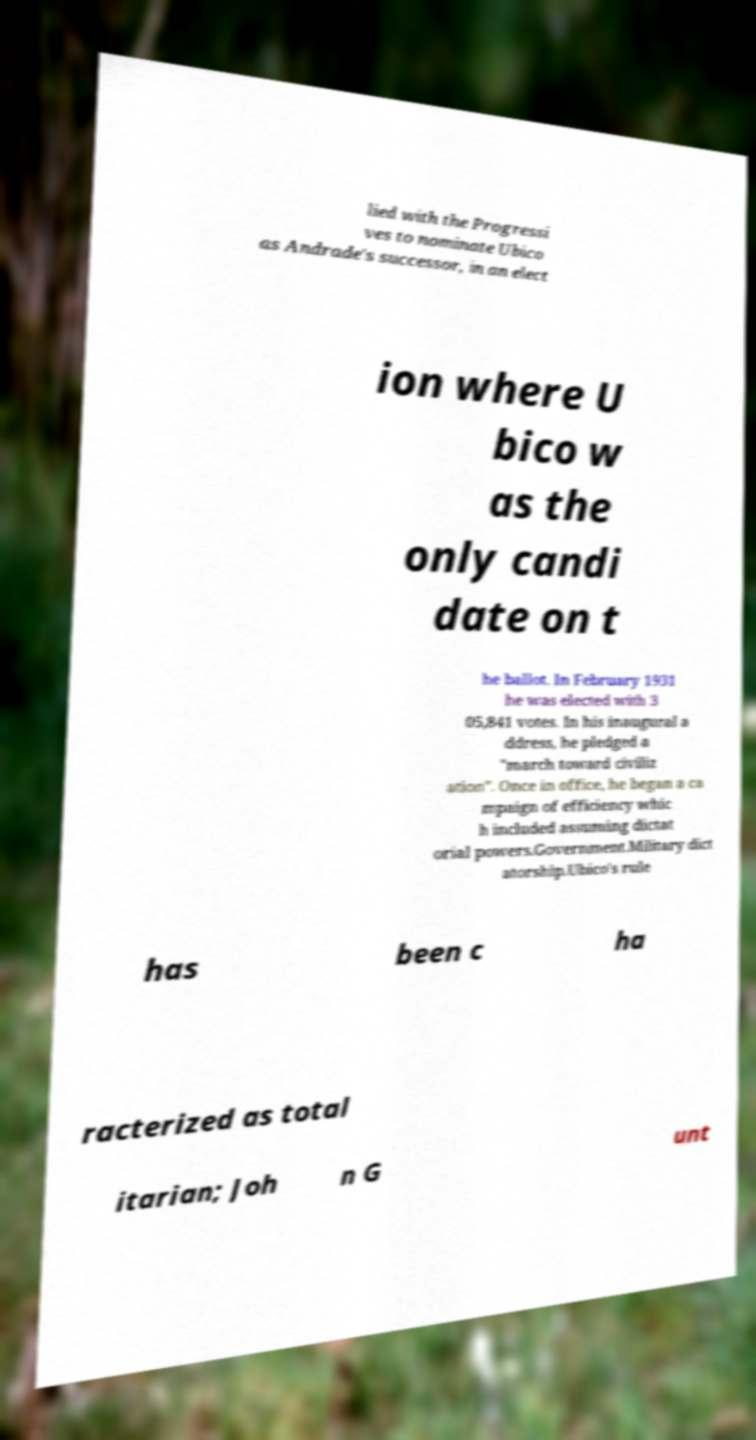For documentation purposes, I need the text within this image transcribed. Could you provide that? lied with the Progressi ves to nominate Ubico as Andrade's successor, in an elect ion where U bico w as the only candi date on t he ballot. In February 1931 he was elected with 3 05,841 votes. In his inaugural a ddress, he pledged a "march toward civiliz ation". Once in office, he began a ca mpaign of efficiency whic h included assuming dictat orial powers.Government.Military dict atorship.Ubico's rule has been c ha racterized as total itarian; Joh n G unt 